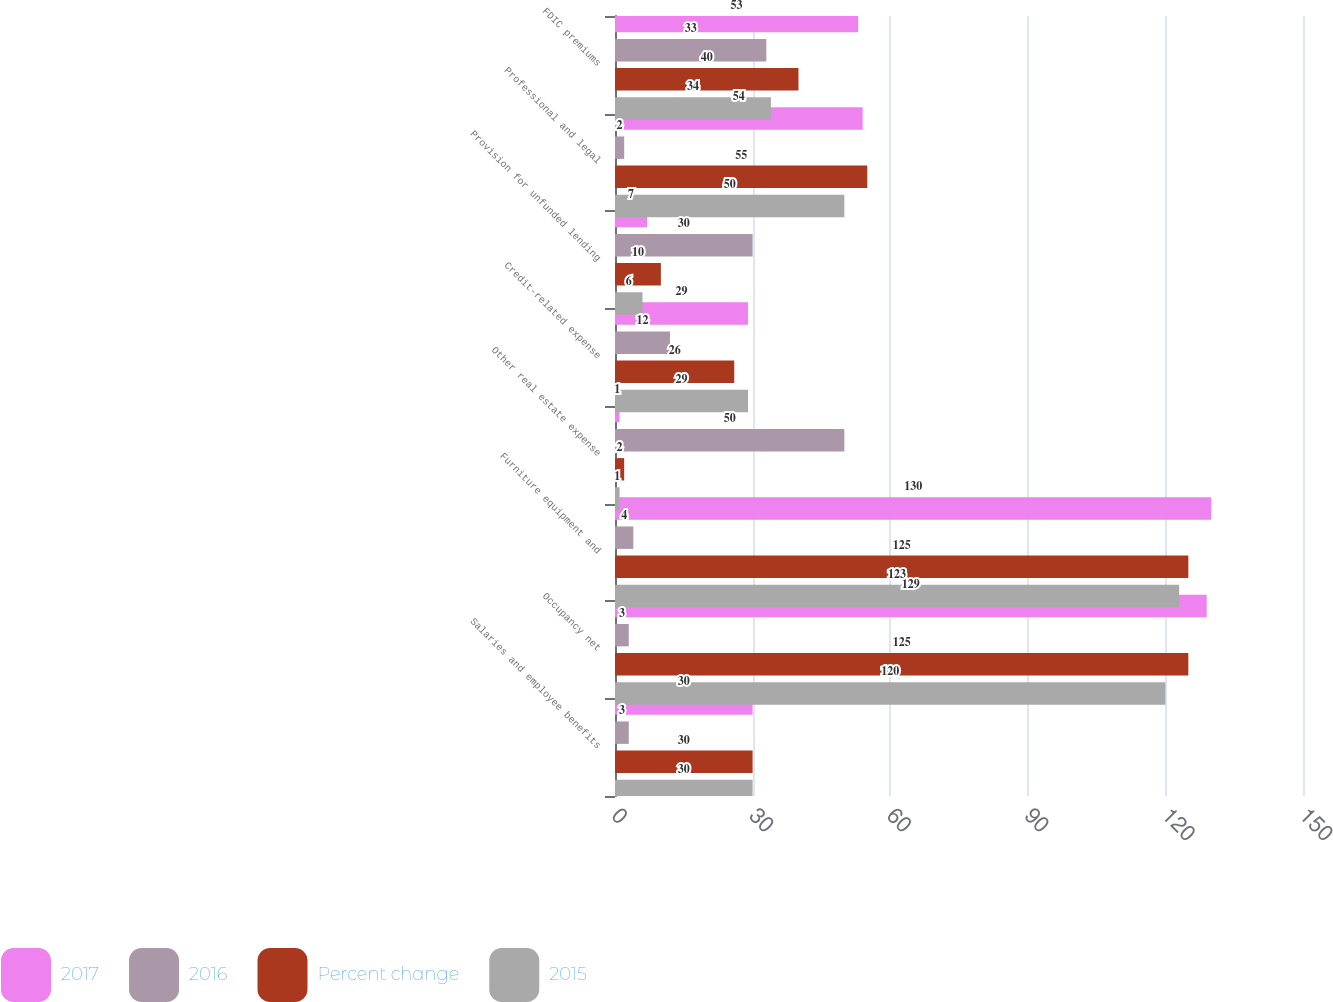<chart> <loc_0><loc_0><loc_500><loc_500><stacked_bar_chart><ecel><fcel>Salaries and employee benefits<fcel>Occupancy net<fcel>Furniture equipment and<fcel>Other real estate expense<fcel>Credit-related expense<fcel>Provision for unfunded lending<fcel>Professional and legal<fcel>FDIC premiums<nl><fcel>2017<fcel>30<fcel>129<fcel>130<fcel>1<fcel>29<fcel>7<fcel>54<fcel>53<nl><fcel>2016<fcel>3<fcel>3<fcel>4<fcel>50<fcel>12<fcel>30<fcel>2<fcel>33<nl><fcel>Percent change<fcel>30<fcel>125<fcel>125<fcel>2<fcel>26<fcel>10<fcel>55<fcel>40<nl><fcel>2015<fcel>30<fcel>120<fcel>123<fcel>1<fcel>29<fcel>6<fcel>50<fcel>34<nl></chart> 